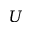<formula> <loc_0><loc_0><loc_500><loc_500>U</formula> 